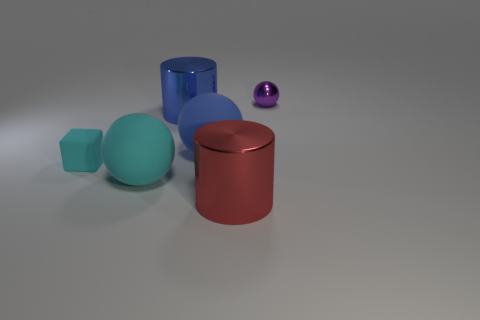Does the small purple thing have the same material as the big blue cylinder?
Your response must be concise. Yes. There is a matte sphere that is the same color as the matte cube; what is its size?
Give a very brief answer. Large. Are there any objects of the same color as the tiny cube?
Provide a short and direct response. Yes. The cube that is the same material as the big cyan thing is what size?
Ensure brevity in your answer.  Small. The big red object that is in front of the tiny object in front of the small object on the right side of the big red shiny cylinder is what shape?
Provide a succinct answer. Cylinder. There is a cyan matte thing that is the same shape as the blue rubber object; what is its size?
Keep it short and to the point. Large. There is a ball that is behind the big cyan thing and to the left of the big red object; what size is it?
Provide a short and direct response. Large. What shape is the matte object that is the same color as the cube?
Offer a very short reply. Sphere. What color is the tiny shiny object?
Make the answer very short. Purple. What size is the ball behind the blue sphere?
Offer a very short reply. Small. 